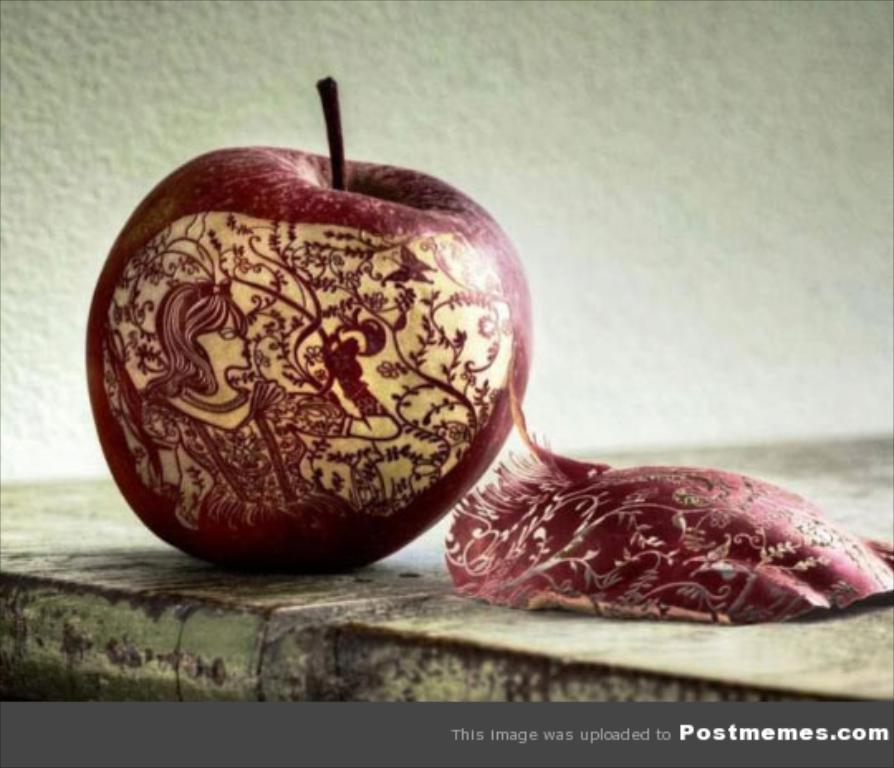What is the main subject of the image? The main subject of the image is an apple with a design on it. Where is the apple located in the image? The apple is on a platform in the image. What can be seen in the background of the image? There is a wall in the background of the image. What is written or depicted at the bottom of the image? There is text at the bottom of the image. What type of toy can be seen playing the drum in the image? There is no toy or drum present in the image; it features an apple with a design on it. Can you describe the sneeze of the person in the image? There is no person present in the image, and therefore no sneeze can be observed. 